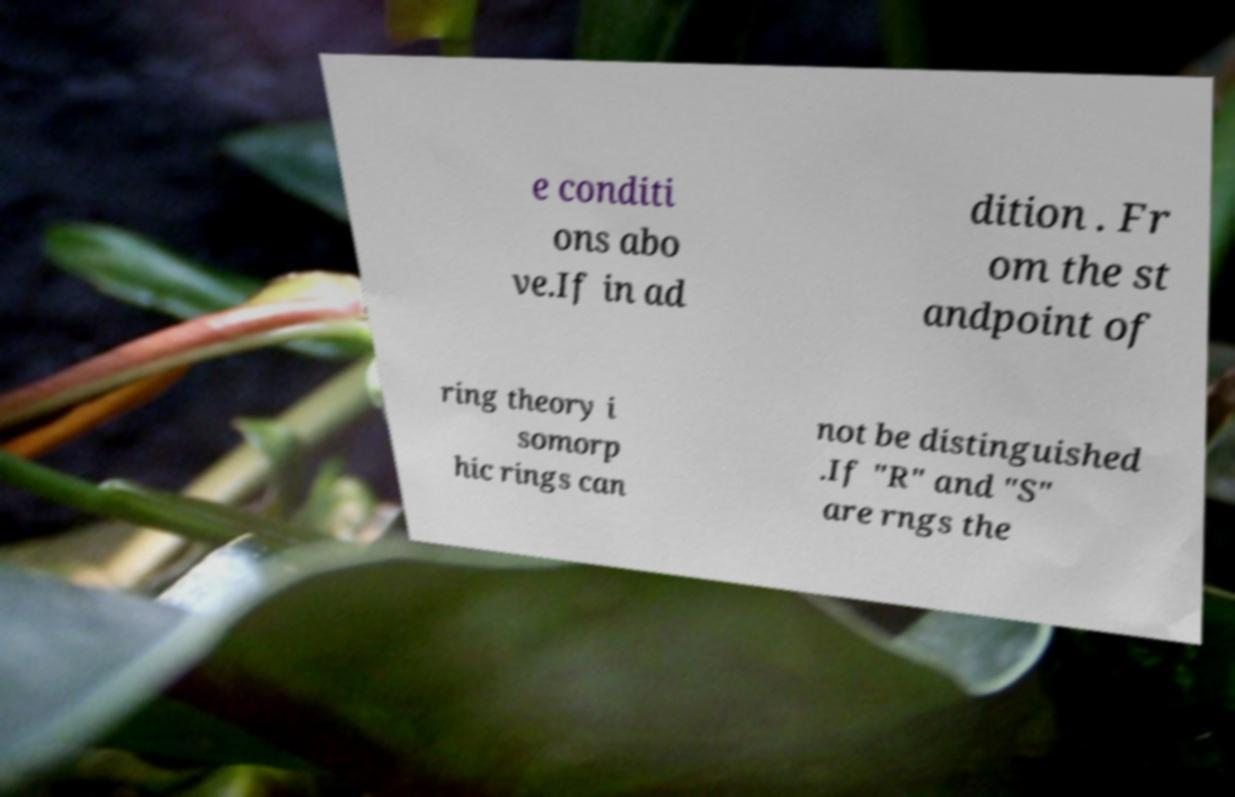Could you assist in decoding the text presented in this image and type it out clearly? e conditi ons abo ve.If in ad dition . Fr om the st andpoint of ring theory i somorp hic rings can not be distinguished .If "R" and "S" are rngs the 